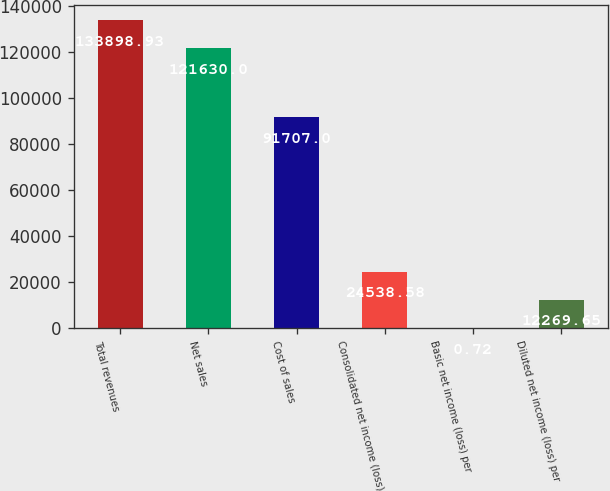Convert chart. <chart><loc_0><loc_0><loc_500><loc_500><bar_chart><fcel>Total revenues<fcel>Net sales<fcel>Cost of sales<fcel>Consolidated net income (loss)<fcel>Basic net income (loss) per<fcel>Diluted net income (loss) per<nl><fcel>133899<fcel>121630<fcel>91707<fcel>24538.6<fcel>0.72<fcel>12269.6<nl></chart> 